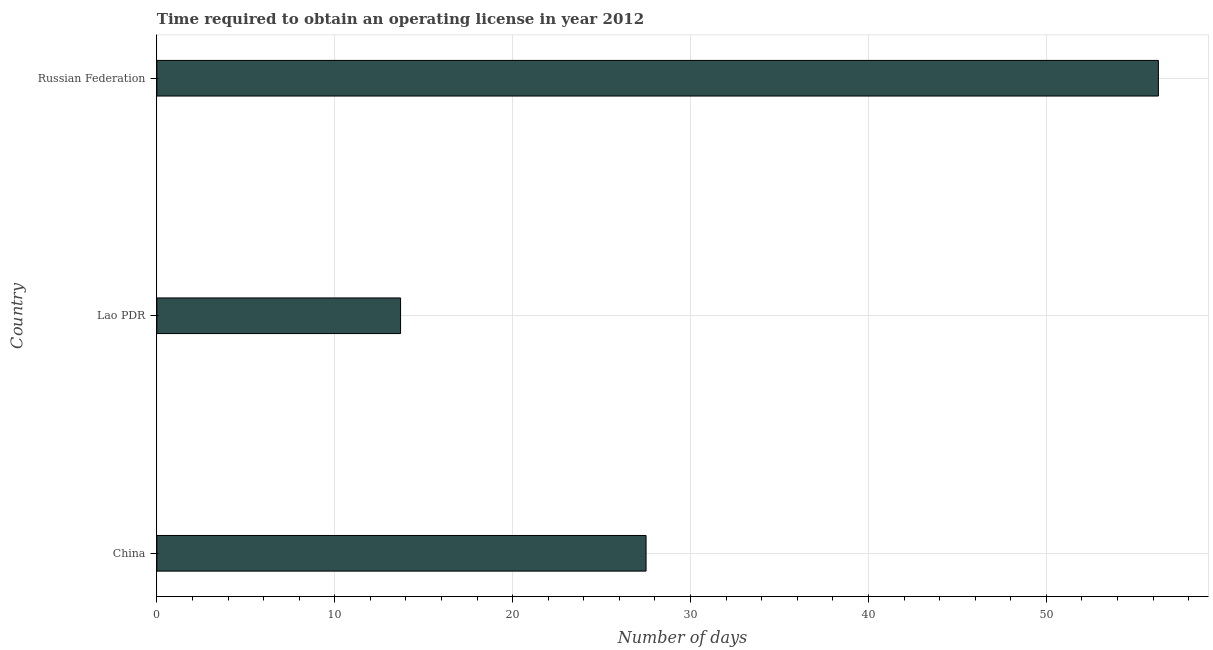Does the graph contain grids?
Ensure brevity in your answer.  Yes. What is the title of the graph?
Keep it short and to the point. Time required to obtain an operating license in year 2012. What is the label or title of the X-axis?
Your response must be concise. Number of days. What is the number of days to obtain operating license in Russian Federation?
Your response must be concise. 56.3. Across all countries, what is the maximum number of days to obtain operating license?
Ensure brevity in your answer.  56.3. In which country was the number of days to obtain operating license maximum?
Ensure brevity in your answer.  Russian Federation. In which country was the number of days to obtain operating license minimum?
Provide a succinct answer. Lao PDR. What is the sum of the number of days to obtain operating license?
Provide a succinct answer. 97.5. What is the difference between the number of days to obtain operating license in China and Lao PDR?
Ensure brevity in your answer.  13.8. What is the average number of days to obtain operating license per country?
Keep it short and to the point. 32.5. What is the median number of days to obtain operating license?
Offer a very short reply. 27.5. In how many countries, is the number of days to obtain operating license greater than 28 days?
Your response must be concise. 1. What is the ratio of the number of days to obtain operating license in China to that in Russian Federation?
Your answer should be very brief. 0.49. What is the difference between the highest and the second highest number of days to obtain operating license?
Make the answer very short. 28.8. What is the difference between the highest and the lowest number of days to obtain operating license?
Provide a succinct answer. 42.6. How many bars are there?
Your answer should be compact. 3. Are all the bars in the graph horizontal?
Provide a short and direct response. Yes. How many countries are there in the graph?
Your response must be concise. 3. What is the Number of days in Lao PDR?
Offer a very short reply. 13.7. What is the Number of days in Russian Federation?
Provide a short and direct response. 56.3. What is the difference between the Number of days in China and Lao PDR?
Your response must be concise. 13.8. What is the difference between the Number of days in China and Russian Federation?
Provide a short and direct response. -28.8. What is the difference between the Number of days in Lao PDR and Russian Federation?
Give a very brief answer. -42.6. What is the ratio of the Number of days in China to that in Lao PDR?
Give a very brief answer. 2.01. What is the ratio of the Number of days in China to that in Russian Federation?
Your answer should be compact. 0.49. What is the ratio of the Number of days in Lao PDR to that in Russian Federation?
Provide a short and direct response. 0.24. 